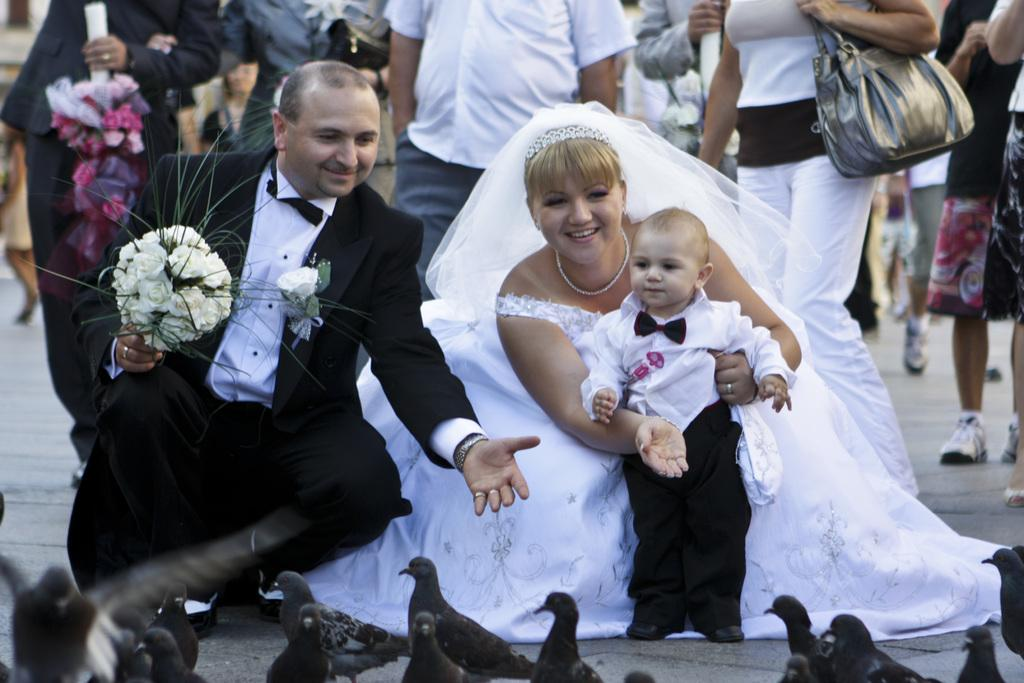How many people are present in the image? There are three people in the image: a man, a woman, and a boy. What are the expressions of the people in the image? Both the man and the woman are smiling in the image. What animals are present in the image? There are pigeons in front of the man, woman, and boy. What is happening in the background of the image? There is a group of people walking in the background of the image, and they are on a road. What type of request is the man making to the church in the image? There is no church present in the image, and therefore no request can be made to it. 